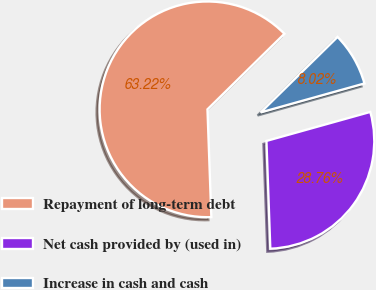Convert chart to OTSL. <chart><loc_0><loc_0><loc_500><loc_500><pie_chart><fcel>Repayment of long-term debt<fcel>Net cash provided by (used in)<fcel>Increase in cash and cash<nl><fcel>63.22%<fcel>28.76%<fcel>8.02%<nl></chart> 